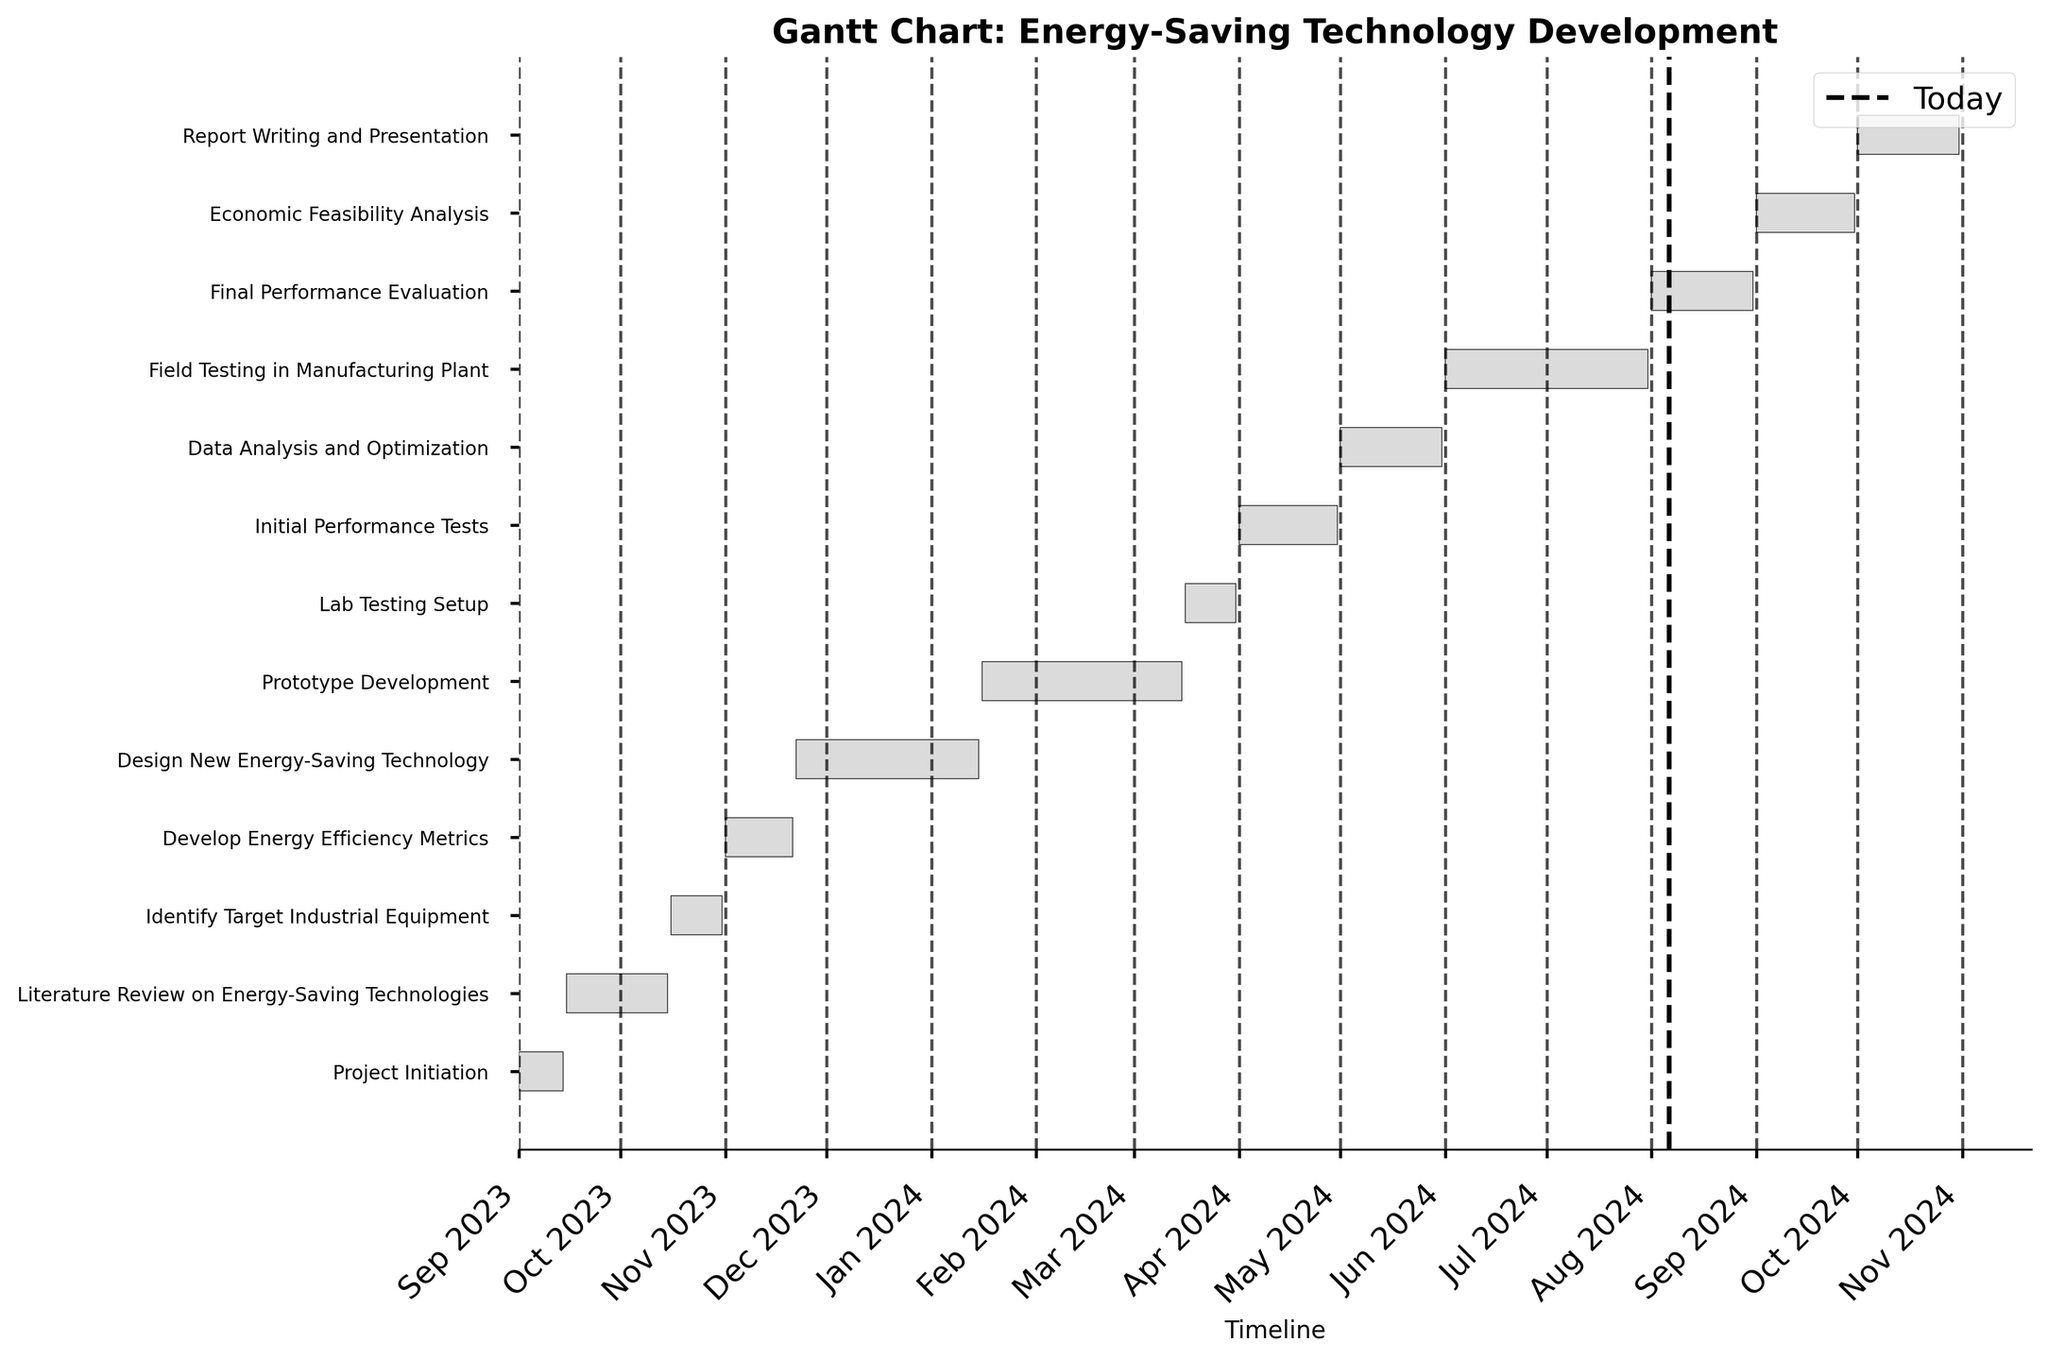What is the title of the Gantt chart? The title is usually shown at the top of the Gantt chart in bold and indicates the subject of the chart.
Answer: Gantt Chart: Energy-Saving Technology Development How many tasks are displayed in the Gantt chart? Count the number of horizontal bars, each representing a task.
Answer: 13 When does the "Prototype Development" task start and end? Find the "Prototype Development" task on the y-axis and look at the starting and ending points along the timeline at the bottom of the chart.
Answer: Starts on 2024-01-16 and ends on 2024-03-15 What is the duration of the "Literature Review on Energy-Saving Technologies" task? The duration is often indicated in days; find the "Literature Review on Energy-Saving Technologies" task and read its duration directly from the chart.
Answer: 31 days Which task has the longest duration? Compare the lengths of the horizontal bars and identify the one that is the longest.
Answer: Field Testing in Manufacturing Plant How does the duration of "Initial Performance Tests" compare to "Final Performance Evaluation"? Find both tasks and compare the lengths of their horizontal bars to see which one is longer.
Answer: Initial Performance Tests is the same duration as Final Performance Evaluation, both are 31 days Calculate the total duration from the "Project Initiation" to "Report Writing and Presentation". Find the start date of "Project Initiation" and the end date of "Report Writing and Presentation" and calculate the total number of days from start to finish.
Answer: 426 days How many tasks are scheduled to occur in 2023? Look at the tasks and their start and end dates to determine how many fall within the calendar year of 2023.
Answer: 4 tasks When does the "Design New Energy-Saving Technology" task end relative to "Prototype Development" starting? Identify the end date of "Design New Energy-Saving Technology" and the start date of "Prototype Development" and compare the two.
Answer: The "Design New Energy-Saving Technology" task ends on the same day "Prototype Development" starts (2024-01-15 and 2024-01-16, respectively) Which phase follows "Lab Testing Setup"? Look to the next task listed after "Lab Testing Setup" in the Gantt chart.
Answer: Initial Performance Tests 